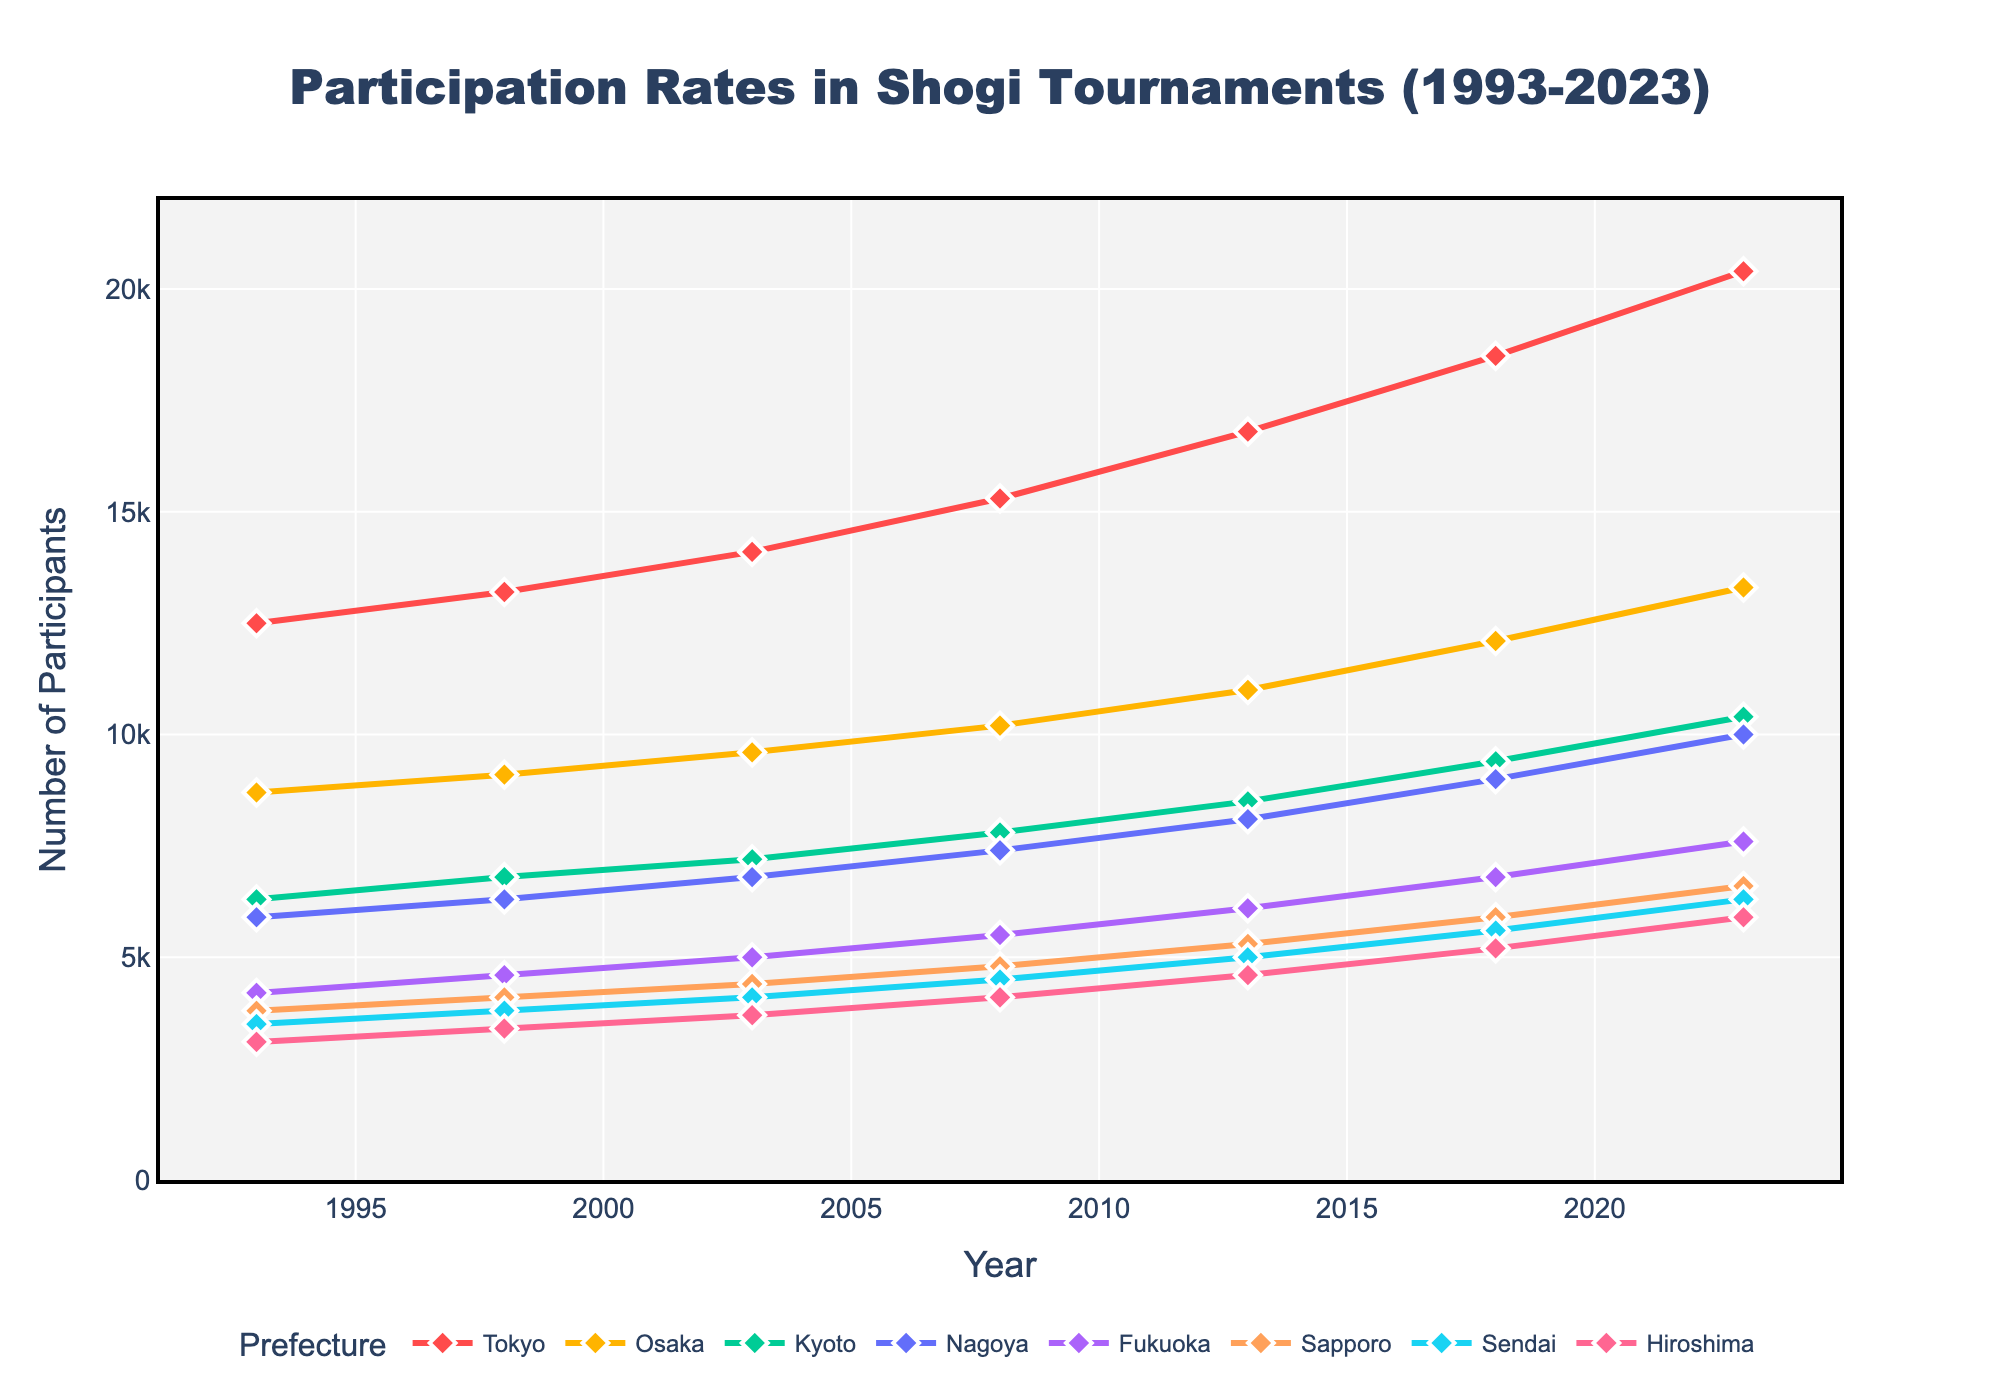What is the overall trend in participation rates in Tokyo from 1993 to 2023? The line representing Tokyo shows a steady upward trend from 12,500 participants in 1993 to 20,400 participants in 2023. The increase is consistent over the entire time period.
Answer: Increasing Which prefecture had the highest participation rate in 2003? By locating the year 2003 on the x-axis and checking the highest data point among the lines, it's clear that Tokyo had the highest participation rate with 14,100 participants.
Answer: Tokyo How does the participation rate in Fukuoka in 2013 compare to that in 2023? In 2013, Fukuoka had 6,100 participants, and by 2023, this number had increased to 7,600. Therefore, participation increased by 1,500 over this 10-year period.
Answer: Increased What's the difference in the highest participation rates between Tokyo and Osaka in 2023? Tokyo had 20,400 participants, while Osaka had 13,300 participants in 2023. The difference, therefore, is 20,400 - 13,300 = 7,100.
Answer: 7,100 Between which two consecutive years did Sendai see the largest increase in participation rates? By checking the difference between consecutive years for Sendai: 
- 1993 to 1998: 3800 - 3500 = 300
- 1998 to 2003: 4100 - 3800 = 300
- 2003 to 2008: 4500 - 4100 = 400
- 2008 to 2013: 5000 - 4500 = 500
- 2013 to 2018: 5600 - 5000 = 600
- 2018 to 2023: 6300 - 5600 = 700
The largest increase was from 2018 to 2023 with an increase of 700 participants.
Answer: 2018 to 2023 What is the average participation rate in Hiroshima across all the years? Adding the Hiroshima participation rates: 3100 + 3400 + 3700 + 4100 + 4600 + 5200 + 5900 = 30,000; dividing by the number of years (7) gives an average: 30,000 / 7 ≈ 4286.
Answer: 4,286 Which prefecture had the lowest participation rate in 1993 and what was the rate? By checking the lowest data point in 1993, it is clear that Hiroshima had the lowest participation rate with 3,100 participants.
Answer: Hiroshima, 3,100 In which year did Kyoto surpass the 10,000 participation mark? By locating the line for Kyoto and checking when it crosses 10,000 on the y-axis, it is evident that Kyoto surpassed the 10,000 mark in the year 2023.
Answer: 2023 How does the participation rate growth from 1993 to 2023 in Sapporo compare to that in Nagoya? For Sapporo: 6,600 in 2023 - 3,800 in 1993 = 2,800. For Nagoya: 10,000 in 2023 - 5,900 in 1993 = 4,100. Nagoya had a more significant increase.
Answer: Nagoya had a larger growth Between 2003 and 2008, which prefecture experienced the greatest percent increase in participation rate? Calculating percentage increase for each prefecture:
- Tokyo: ((15300 - 14100) / 14100) * 100 = ~8.5%
- Osaka: ((10200 - 9600) / 9600) * 100 = ~6.25%
- Kyoto: ((7800 - 7200) / 7200) * 100 = ~8.33%
- Nagoya: ((7400 - 6800) / 6800) * 100 = ~8.82%
- Fukuoka: ((5500 - 5000) / 5000) * 100 = ~10%
- Sapporo: ((4800 - 4400) / 4400) * 100 = ~9.1%
- Sendai: ((4500 - 4100) / 4100) * 100 = ~9.76%
- Hiroshima: ((4100 - 3700) / 3700) * 100 = ~10.81%
Hiroshima experienced the greatest percent increase (~10.81%).
Answer: Hiroshima 